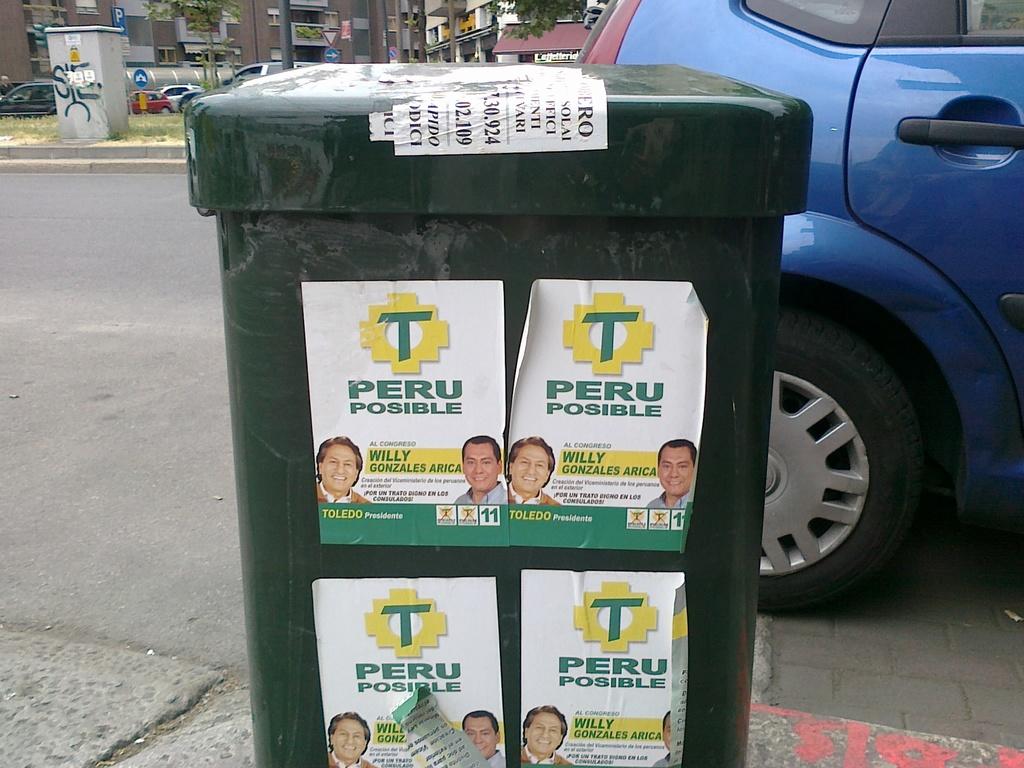What are the flyers for?
Ensure brevity in your answer.  Peru posible. What country is on the flyer?
Your response must be concise. Peru. 